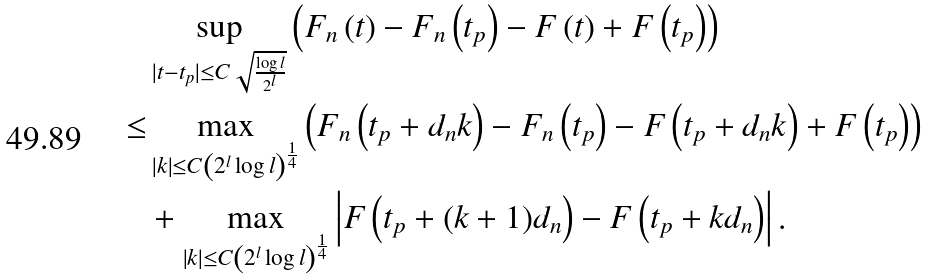<formula> <loc_0><loc_0><loc_500><loc_500>& \sup _ { | t - t _ { p } | \leq C \sqrt { \frac { \log l } { 2 ^ { l } } } } \left ( F _ { n } \left ( t \right ) - F _ { n } \left ( t _ { p } \right ) - F \left ( t \right ) + F \left ( t _ { p } \right ) \right ) \\ \leq & \max _ { \left | k \right | \leq C \left ( 2 ^ { l } \log l \right ) ^ { \frac { 1 } { 4 } } } \left ( F _ { n } \left ( t _ { p } + d _ { n } k \right ) - F _ { n } \left ( t _ { p } \right ) - F \left ( t _ { p } + d _ { n } k \right ) + F \left ( t _ { p } \right ) \right ) \\ & + \max _ { \left | k \right | \leq C \left ( 2 ^ { l } \log l \right ) ^ { \frac { 1 } { 4 } } } \left | F \left ( t _ { p } + ( k + 1 ) d _ { n } \right ) - F \left ( t _ { p } + k d _ { n } \right ) \right | .</formula> 